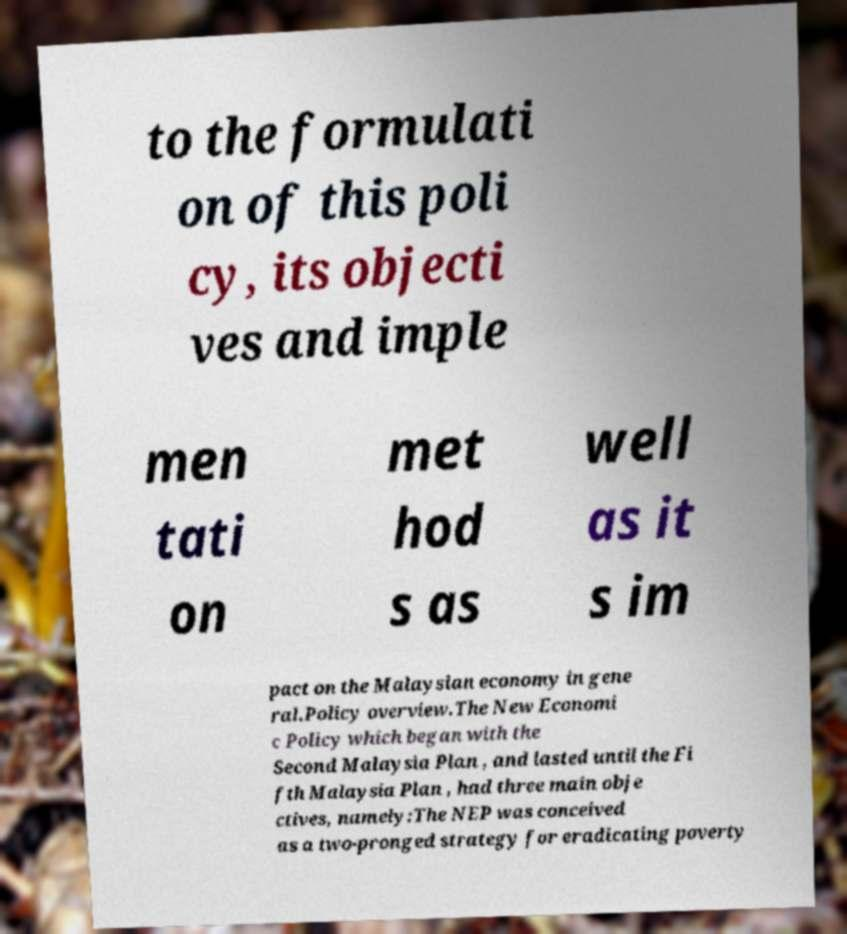Please read and relay the text visible in this image. What does it say? to the formulati on of this poli cy, its objecti ves and imple men tati on met hod s as well as it s im pact on the Malaysian economy in gene ral.Policy overview.The New Economi c Policy which began with the Second Malaysia Plan , and lasted until the Fi fth Malaysia Plan , had three main obje ctives, namely:The NEP was conceived as a two-pronged strategy for eradicating poverty 